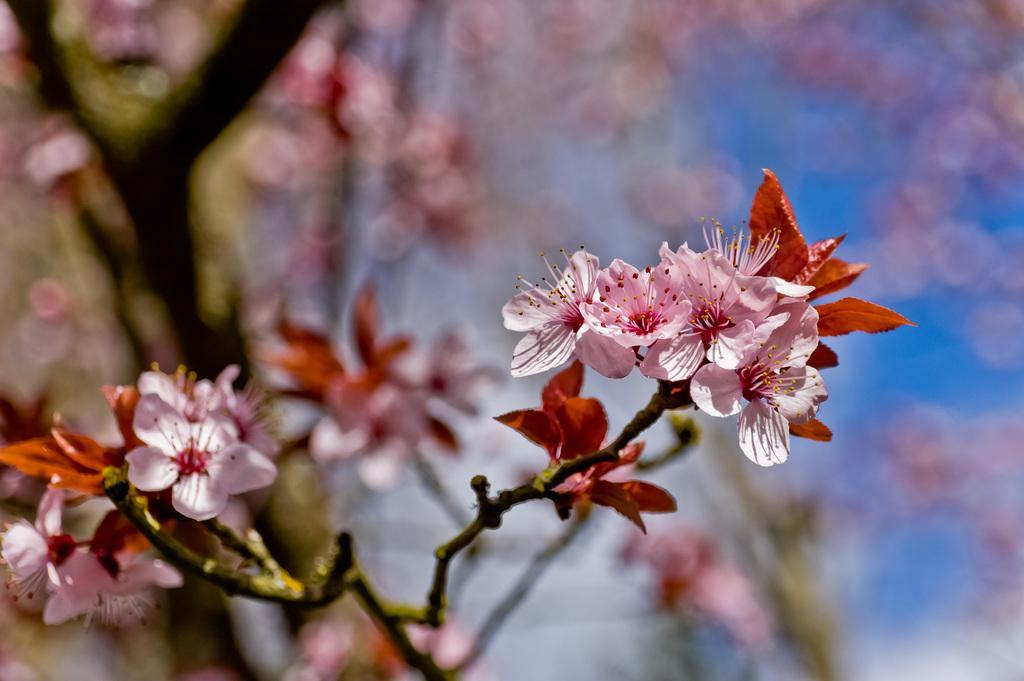Could you give a brief overview of what you see in this image? In the foreground of the picture there are flowers, leaves and stem. The background is blurred. In the background there is a tree. 